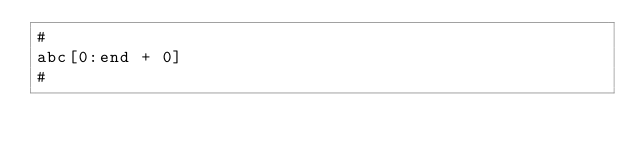Convert code to text. <code><loc_0><loc_0><loc_500><loc_500><_Python_>#
abc[0:end + 0]
#
</code> 